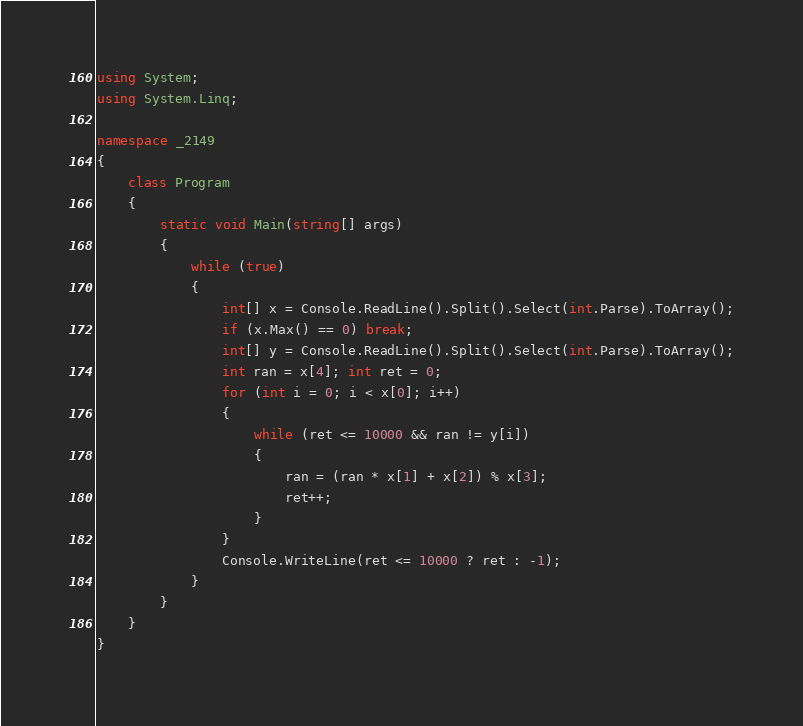Convert code to text. <code><loc_0><loc_0><loc_500><loc_500><_C#_>using System;
using System.Linq;

namespace _2149
{
    class Program
    {
        static void Main(string[] args)
        {
            while (true)
            {
                int[] x = Console.ReadLine().Split().Select(int.Parse).ToArray();
                if (x.Max() == 0) break;
                int[] y = Console.ReadLine().Split().Select(int.Parse).ToArray();
                int ran = x[4]; int ret = 0;
                for (int i = 0; i < x[0]; i++)
                {
                    while (ret <= 10000 && ran != y[i])
                    {
                        ran = (ran * x[1] + x[2]) % x[3];
                        ret++;
                    }
                }
                Console.WriteLine(ret <= 10000 ? ret : -1);
            }
        }
    }
}
</code> 